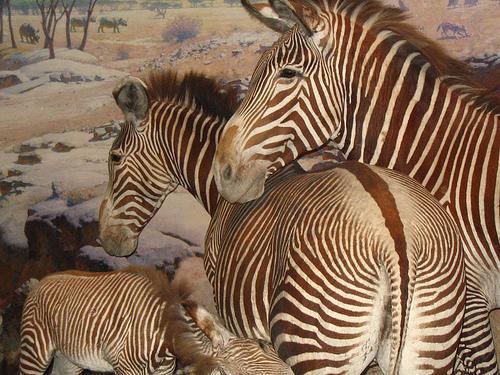What is in the picture?
Be succinct. Zebras. Are these animals in their natural habitat?
Keep it brief. No. How many zebras are there?
Write a very short answer. 3. Are these animals alive?
Answer briefly. Yes. 